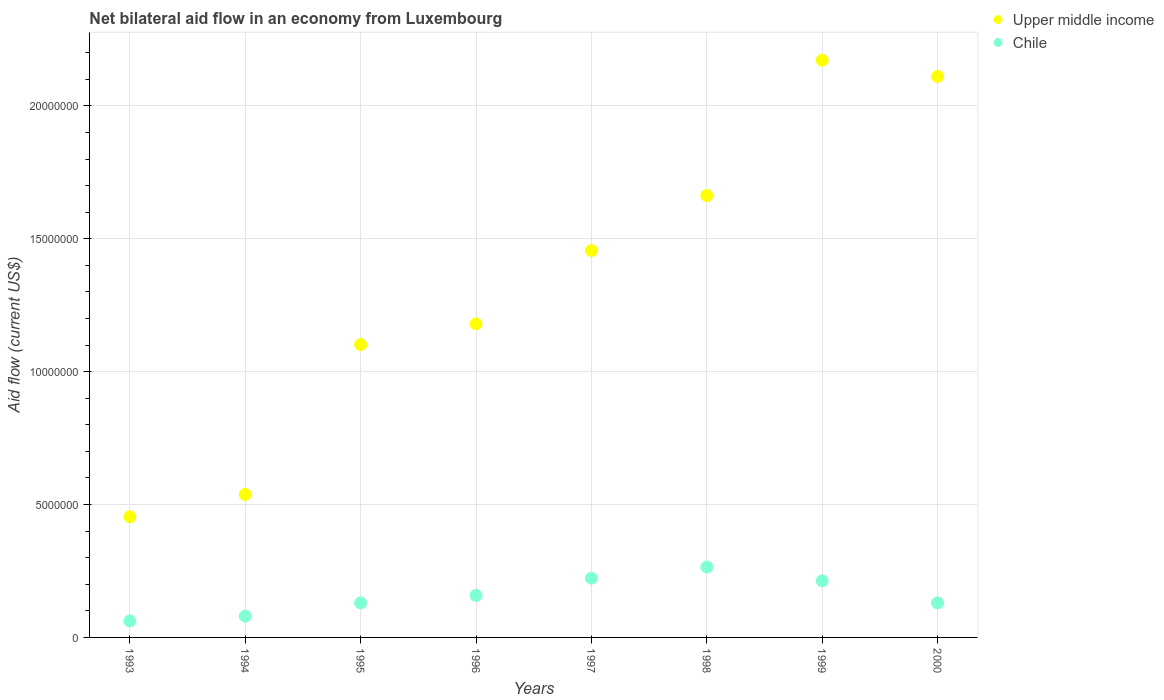Is the number of dotlines equal to the number of legend labels?
Provide a short and direct response. Yes. What is the net bilateral aid flow in Chile in 2000?
Keep it short and to the point. 1.30e+06. Across all years, what is the maximum net bilateral aid flow in Chile?
Offer a very short reply. 2.65e+06. Across all years, what is the minimum net bilateral aid flow in Upper middle income?
Your response must be concise. 4.54e+06. In which year was the net bilateral aid flow in Chile minimum?
Ensure brevity in your answer.  1993. What is the total net bilateral aid flow in Upper middle income in the graph?
Your response must be concise. 1.07e+08. What is the difference between the net bilateral aid flow in Upper middle income in 1998 and that in 1999?
Keep it short and to the point. -5.09e+06. What is the difference between the net bilateral aid flow in Chile in 1994 and the net bilateral aid flow in Upper middle income in 1996?
Give a very brief answer. -1.10e+07. What is the average net bilateral aid flow in Upper middle income per year?
Make the answer very short. 1.33e+07. In the year 1993, what is the difference between the net bilateral aid flow in Upper middle income and net bilateral aid flow in Chile?
Provide a short and direct response. 3.92e+06. In how many years, is the net bilateral aid flow in Upper middle income greater than 5000000 US$?
Provide a short and direct response. 7. What is the ratio of the net bilateral aid flow in Chile in 1993 to that in 1994?
Your answer should be very brief. 0.78. Is the net bilateral aid flow in Chile in 1994 less than that in 1998?
Provide a short and direct response. Yes. What is the difference between the highest and the second highest net bilateral aid flow in Chile?
Provide a succinct answer. 4.20e+05. What is the difference between the highest and the lowest net bilateral aid flow in Upper middle income?
Your response must be concise. 1.72e+07. Is the sum of the net bilateral aid flow in Chile in 1994 and 1998 greater than the maximum net bilateral aid flow in Upper middle income across all years?
Offer a very short reply. No. Does the net bilateral aid flow in Chile monotonically increase over the years?
Offer a terse response. No. Where does the legend appear in the graph?
Your response must be concise. Top right. How many legend labels are there?
Provide a short and direct response. 2. How are the legend labels stacked?
Keep it short and to the point. Vertical. What is the title of the graph?
Provide a short and direct response. Net bilateral aid flow in an economy from Luxembourg. What is the Aid flow (current US$) of Upper middle income in 1993?
Offer a terse response. 4.54e+06. What is the Aid flow (current US$) of Chile in 1993?
Provide a succinct answer. 6.20e+05. What is the Aid flow (current US$) of Upper middle income in 1994?
Your answer should be compact. 5.38e+06. What is the Aid flow (current US$) of Upper middle income in 1995?
Ensure brevity in your answer.  1.10e+07. What is the Aid flow (current US$) in Chile in 1995?
Make the answer very short. 1.30e+06. What is the Aid flow (current US$) in Upper middle income in 1996?
Provide a short and direct response. 1.18e+07. What is the Aid flow (current US$) in Chile in 1996?
Make the answer very short. 1.58e+06. What is the Aid flow (current US$) of Upper middle income in 1997?
Offer a terse response. 1.46e+07. What is the Aid flow (current US$) of Chile in 1997?
Provide a succinct answer. 2.23e+06. What is the Aid flow (current US$) in Upper middle income in 1998?
Make the answer very short. 1.66e+07. What is the Aid flow (current US$) of Chile in 1998?
Your response must be concise. 2.65e+06. What is the Aid flow (current US$) of Upper middle income in 1999?
Make the answer very short. 2.17e+07. What is the Aid flow (current US$) of Chile in 1999?
Your answer should be compact. 2.13e+06. What is the Aid flow (current US$) in Upper middle income in 2000?
Give a very brief answer. 2.11e+07. What is the Aid flow (current US$) of Chile in 2000?
Offer a very short reply. 1.30e+06. Across all years, what is the maximum Aid flow (current US$) in Upper middle income?
Offer a terse response. 2.17e+07. Across all years, what is the maximum Aid flow (current US$) in Chile?
Provide a short and direct response. 2.65e+06. Across all years, what is the minimum Aid flow (current US$) in Upper middle income?
Offer a very short reply. 4.54e+06. Across all years, what is the minimum Aid flow (current US$) in Chile?
Provide a succinct answer. 6.20e+05. What is the total Aid flow (current US$) in Upper middle income in the graph?
Your answer should be very brief. 1.07e+08. What is the total Aid flow (current US$) in Chile in the graph?
Your answer should be very brief. 1.26e+07. What is the difference between the Aid flow (current US$) of Upper middle income in 1993 and that in 1994?
Keep it short and to the point. -8.40e+05. What is the difference between the Aid flow (current US$) in Upper middle income in 1993 and that in 1995?
Ensure brevity in your answer.  -6.48e+06. What is the difference between the Aid flow (current US$) in Chile in 1993 and that in 1995?
Ensure brevity in your answer.  -6.80e+05. What is the difference between the Aid flow (current US$) in Upper middle income in 1993 and that in 1996?
Offer a very short reply. -7.26e+06. What is the difference between the Aid flow (current US$) in Chile in 1993 and that in 1996?
Provide a short and direct response. -9.60e+05. What is the difference between the Aid flow (current US$) in Upper middle income in 1993 and that in 1997?
Make the answer very short. -1.00e+07. What is the difference between the Aid flow (current US$) of Chile in 1993 and that in 1997?
Give a very brief answer. -1.61e+06. What is the difference between the Aid flow (current US$) of Upper middle income in 1993 and that in 1998?
Provide a succinct answer. -1.21e+07. What is the difference between the Aid flow (current US$) of Chile in 1993 and that in 1998?
Offer a terse response. -2.03e+06. What is the difference between the Aid flow (current US$) of Upper middle income in 1993 and that in 1999?
Give a very brief answer. -1.72e+07. What is the difference between the Aid flow (current US$) of Chile in 1993 and that in 1999?
Ensure brevity in your answer.  -1.51e+06. What is the difference between the Aid flow (current US$) in Upper middle income in 1993 and that in 2000?
Ensure brevity in your answer.  -1.66e+07. What is the difference between the Aid flow (current US$) of Chile in 1993 and that in 2000?
Offer a terse response. -6.80e+05. What is the difference between the Aid flow (current US$) in Upper middle income in 1994 and that in 1995?
Your response must be concise. -5.64e+06. What is the difference between the Aid flow (current US$) in Chile in 1994 and that in 1995?
Give a very brief answer. -5.00e+05. What is the difference between the Aid flow (current US$) in Upper middle income in 1994 and that in 1996?
Provide a short and direct response. -6.42e+06. What is the difference between the Aid flow (current US$) of Chile in 1994 and that in 1996?
Your answer should be very brief. -7.80e+05. What is the difference between the Aid flow (current US$) of Upper middle income in 1994 and that in 1997?
Give a very brief answer. -9.18e+06. What is the difference between the Aid flow (current US$) of Chile in 1994 and that in 1997?
Provide a succinct answer. -1.43e+06. What is the difference between the Aid flow (current US$) of Upper middle income in 1994 and that in 1998?
Offer a terse response. -1.12e+07. What is the difference between the Aid flow (current US$) in Chile in 1994 and that in 1998?
Your answer should be compact. -1.85e+06. What is the difference between the Aid flow (current US$) of Upper middle income in 1994 and that in 1999?
Provide a succinct answer. -1.63e+07. What is the difference between the Aid flow (current US$) of Chile in 1994 and that in 1999?
Provide a succinct answer. -1.33e+06. What is the difference between the Aid flow (current US$) in Upper middle income in 1994 and that in 2000?
Keep it short and to the point. -1.57e+07. What is the difference between the Aid flow (current US$) in Chile in 1994 and that in 2000?
Keep it short and to the point. -5.00e+05. What is the difference between the Aid flow (current US$) in Upper middle income in 1995 and that in 1996?
Your answer should be very brief. -7.80e+05. What is the difference between the Aid flow (current US$) of Chile in 1995 and that in 1996?
Make the answer very short. -2.80e+05. What is the difference between the Aid flow (current US$) of Upper middle income in 1995 and that in 1997?
Offer a terse response. -3.54e+06. What is the difference between the Aid flow (current US$) of Chile in 1995 and that in 1997?
Your response must be concise. -9.30e+05. What is the difference between the Aid flow (current US$) of Upper middle income in 1995 and that in 1998?
Keep it short and to the point. -5.61e+06. What is the difference between the Aid flow (current US$) in Chile in 1995 and that in 1998?
Make the answer very short. -1.35e+06. What is the difference between the Aid flow (current US$) in Upper middle income in 1995 and that in 1999?
Your response must be concise. -1.07e+07. What is the difference between the Aid flow (current US$) of Chile in 1995 and that in 1999?
Give a very brief answer. -8.30e+05. What is the difference between the Aid flow (current US$) of Upper middle income in 1995 and that in 2000?
Your response must be concise. -1.01e+07. What is the difference between the Aid flow (current US$) of Upper middle income in 1996 and that in 1997?
Your answer should be compact. -2.76e+06. What is the difference between the Aid flow (current US$) in Chile in 1996 and that in 1997?
Your answer should be very brief. -6.50e+05. What is the difference between the Aid flow (current US$) of Upper middle income in 1996 and that in 1998?
Offer a terse response. -4.83e+06. What is the difference between the Aid flow (current US$) in Chile in 1996 and that in 1998?
Provide a succinct answer. -1.07e+06. What is the difference between the Aid flow (current US$) of Upper middle income in 1996 and that in 1999?
Keep it short and to the point. -9.92e+06. What is the difference between the Aid flow (current US$) of Chile in 1996 and that in 1999?
Provide a succinct answer. -5.50e+05. What is the difference between the Aid flow (current US$) of Upper middle income in 1996 and that in 2000?
Your answer should be compact. -9.31e+06. What is the difference between the Aid flow (current US$) in Chile in 1996 and that in 2000?
Provide a short and direct response. 2.80e+05. What is the difference between the Aid flow (current US$) in Upper middle income in 1997 and that in 1998?
Keep it short and to the point. -2.07e+06. What is the difference between the Aid flow (current US$) in Chile in 1997 and that in 1998?
Keep it short and to the point. -4.20e+05. What is the difference between the Aid flow (current US$) of Upper middle income in 1997 and that in 1999?
Provide a succinct answer. -7.16e+06. What is the difference between the Aid flow (current US$) in Chile in 1997 and that in 1999?
Make the answer very short. 1.00e+05. What is the difference between the Aid flow (current US$) of Upper middle income in 1997 and that in 2000?
Give a very brief answer. -6.55e+06. What is the difference between the Aid flow (current US$) in Chile in 1997 and that in 2000?
Keep it short and to the point. 9.30e+05. What is the difference between the Aid flow (current US$) of Upper middle income in 1998 and that in 1999?
Your answer should be very brief. -5.09e+06. What is the difference between the Aid flow (current US$) of Chile in 1998 and that in 1999?
Your response must be concise. 5.20e+05. What is the difference between the Aid flow (current US$) of Upper middle income in 1998 and that in 2000?
Offer a terse response. -4.48e+06. What is the difference between the Aid flow (current US$) of Chile in 1998 and that in 2000?
Offer a terse response. 1.35e+06. What is the difference between the Aid flow (current US$) of Chile in 1999 and that in 2000?
Offer a terse response. 8.30e+05. What is the difference between the Aid flow (current US$) of Upper middle income in 1993 and the Aid flow (current US$) of Chile in 1994?
Give a very brief answer. 3.74e+06. What is the difference between the Aid flow (current US$) of Upper middle income in 1993 and the Aid flow (current US$) of Chile in 1995?
Ensure brevity in your answer.  3.24e+06. What is the difference between the Aid flow (current US$) in Upper middle income in 1993 and the Aid flow (current US$) in Chile in 1996?
Provide a short and direct response. 2.96e+06. What is the difference between the Aid flow (current US$) of Upper middle income in 1993 and the Aid flow (current US$) of Chile in 1997?
Give a very brief answer. 2.31e+06. What is the difference between the Aid flow (current US$) of Upper middle income in 1993 and the Aid flow (current US$) of Chile in 1998?
Ensure brevity in your answer.  1.89e+06. What is the difference between the Aid flow (current US$) in Upper middle income in 1993 and the Aid flow (current US$) in Chile in 1999?
Provide a short and direct response. 2.41e+06. What is the difference between the Aid flow (current US$) of Upper middle income in 1993 and the Aid flow (current US$) of Chile in 2000?
Provide a short and direct response. 3.24e+06. What is the difference between the Aid flow (current US$) in Upper middle income in 1994 and the Aid flow (current US$) in Chile in 1995?
Your answer should be very brief. 4.08e+06. What is the difference between the Aid flow (current US$) of Upper middle income in 1994 and the Aid flow (current US$) of Chile in 1996?
Offer a very short reply. 3.80e+06. What is the difference between the Aid flow (current US$) in Upper middle income in 1994 and the Aid flow (current US$) in Chile in 1997?
Give a very brief answer. 3.15e+06. What is the difference between the Aid flow (current US$) of Upper middle income in 1994 and the Aid flow (current US$) of Chile in 1998?
Keep it short and to the point. 2.73e+06. What is the difference between the Aid flow (current US$) in Upper middle income in 1994 and the Aid flow (current US$) in Chile in 1999?
Provide a succinct answer. 3.25e+06. What is the difference between the Aid flow (current US$) of Upper middle income in 1994 and the Aid flow (current US$) of Chile in 2000?
Provide a succinct answer. 4.08e+06. What is the difference between the Aid flow (current US$) in Upper middle income in 1995 and the Aid flow (current US$) in Chile in 1996?
Give a very brief answer. 9.44e+06. What is the difference between the Aid flow (current US$) in Upper middle income in 1995 and the Aid flow (current US$) in Chile in 1997?
Give a very brief answer. 8.79e+06. What is the difference between the Aid flow (current US$) of Upper middle income in 1995 and the Aid flow (current US$) of Chile in 1998?
Ensure brevity in your answer.  8.37e+06. What is the difference between the Aid flow (current US$) of Upper middle income in 1995 and the Aid flow (current US$) of Chile in 1999?
Provide a short and direct response. 8.89e+06. What is the difference between the Aid flow (current US$) of Upper middle income in 1995 and the Aid flow (current US$) of Chile in 2000?
Offer a very short reply. 9.72e+06. What is the difference between the Aid flow (current US$) of Upper middle income in 1996 and the Aid flow (current US$) of Chile in 1997?
Provide a succinct answer. 9.57e+06. What is the difference between the Aid flow (current US$) of Upper middle income in 1996 and the Aid flow (current US$) of Chile in 1998?
Offer a very short reply. 9.15e+06. What is the difference between the Aid flow (current US$) in Upper middle income in 1996 and the Aid flow (current US$) in Chile in 1999?
Make the answer very short. 9.67e+06. What is the difference between the Aid flow (current US$) in Upper middle income in 1996 and the Aid flow (current US$) in Chile in 2000?
Your response must be concise. 1.05e+07. What is the difference between the Aid flow (current US$) of Upper middle income in 1997 and the Aid flow (current US$) of Chile in 1998?
Your response must be concise. 1.19e+07. What is the difference between the Aid flow (current US$) in Upper middle income in 1997 and the Aid flow (current US$) in Chile in 1999?
Make the answer very short. 1.24e+07. What is the difference between the Aid flow (current US$) of Upper middle income in 1997 and the Aid flow (current US$) of Chile in 2000?
Ensure brevity in your answer.  1.33e+07. What is the difference between the Aid flow (current US$) of Upper middle income in 1998 and the Aid flow (current US$) of Chile in 1999?
Provide a short and direct response. 1.45e+07. What is the difference between the Aid flow (current US$) in Upper middle income in 1998 and the Aid flow (current US$) in Chile in 2000?
Give a very brief answer. 1.53e+07. What is the difference between the Aid flow (current US$) of Upper middle income in 1999 and the Aid flow (current US$) of Chile in 2000?
Provide a short and direct response. 2.04e+07. What is the average Aid flow (current US$) of Upper middle income per year?
Make the answer very short. 1.33e+07. What is the average Aid flow (current US$) of Chile per year?
Ensure brevity in your answer.  1.58e+06. In the year 1993, what is the difference between the Aid flow (current US$) in Upper middle income and Aid flow (current US$) in Chile?
Your response must be concise. 3.92e+06. In the year 1994, what is the difference between the Aid flow (current US$) of Upper middle income and Aid flow (current US$) of Chile?
Provide a short and direct response. 4.58e+06. In the year 1995, what is the difference between the Aid flow (current US$) of Upper middle income and Aid flow (current US$) of Chile?
Offer a terse response. 9.72e+06. In the year 1996, what is the difference between the Aid flow (current US$) of Upper middle income and Aid flow (current US$) of Chile?
Ensure brevity in your answer.  1.02e+07. In the year 1997, what is the difference between the Aid flow (current US$) in Upper middle income and Aid flow (current US$) in Chile?
Provide a succinct answer. 1.23e+07. In the year 1998, what is the difference between the Aid flow (current US$) in Upper middle income and Aid flow (current US$) in Chile?
Ensure brevity in your answer.  1.40e+07. In the year 1999, what is the difference between the Aid flow (current US$) in Upper middle income and Aid flow (current US$) in Chile?
Your answer should be very brief. 1.96e+07. In the year 2000, what is the difference between the Aid flow (current US$) of Upper middle income and Aid flow (current US$) of Chile?
Your answer should be very brief. 1.98e+07. What is the ratio of the Aid flow (current US$) in Upper middle income in 1993 to that in 1994?
Ensure brevity in your answer.  0.84. What is the ratio of the Aid flow (current US$) of Chile in 1993 to that in 1994?
Your response must be concise. 0.78. What is the ratio of the Aid flow (current US$) in Upper middle income in 1993 to that in 1995?
Make the answer very short. 0.41. What is the ratio of the Aid flow (current US$) of Chile in 1993 to that in 1995?
Offer a very short reply. 0.48. What is the ratio of the Aid flow (current US$) in Upper middle income in 1993 to that in 1996?
Give a very brief answer. 0.38. What is the ratio of the Aid flow (current US$) in Chile in 1993 to that in 1996?
Offer a terse response. 0.39. What is the ratio of the Aid flow (current US$) of Upper middle income in 1993 to that in 1997?
Offer a terse response. 0.31. What is the ratio of the Aid flow (current US$) of Chile in 1993 to that in 1997?
Your answer should be very brief. 0.28. What is the ratio of the Aid flow (current US$) in Upper middle income in 1993 to that in 1998?
Offer a terse response. 0.27. What is the ratio of the Aid flow (current US$) of Chile in 1993 to that in 1998?
Give a very brief answer. 0.23. What is the ratio of the Aid flow (current US$) of Upper middle income in 1993 to that in 1999?
Give a very brief answer. 0.21. What is the ratio of the Aid flow (current US$) in Chile in 1993 to that in 1999?
Provide a succinct answer. 0.29. What is the ratio of the Aid flow (current US$) of Upper middle income in 1993 to that in 2000?
Offer a terse response. 0.22. What is the ratio of the Aid flow (current US$) in Chile in 1993 to that in 2000?
Offer a terse response. 0.48. What is the ratio of the Aid flow (current US$) of Upper middle income in 1994 to that in 1995?
Keep it short and to the point. 0.49. What is the ratio of the Aid flow (current US$) of Chile in 1994 to that in 1995?
Your response must be concise. 0.62. What is the ratio of the Aid flow (current US$) in Upper middle income in 1994 to that in 1996?
Your response must be concise. 0.46. What is the ratio of the Aid flow (current US$) of Chile in 1994 to that in 1996?
Offer a very short reply. 0.51. What is the ratio of the Aid flow (current US$) in Upper middle income in 1994 to that in 1997?
Your answer should be very brief. 0.37. What is the ratio of the Aid flow (current US$) in Chile in 1994 to that in 1997?
Your response must be concise. 0.36. What is the ratio of the Aid flow (current US$) in Upper middle income in 1994 to that in 1998?
Offer a very short reply. 0.32. What is the ratio of the Aid flow (current US$) of Chile in 1994 to that in 1998?
Offer a terse response. 0.3. What is the ratio of the Aid flow (current US$) of Upper middle income in 1994 to that in 1999?
Keep it short and to the point. 0.25. What is the ratio of the Aid flow (current US$) in Chile in 1994 to that in 1999?
Make the answer very short. 0.38. What is the ratio of the Aid flow (current US$) in Upper middle income in 1994 to that in 2000?
Your response must be concise. 0.25. What is the ratio of the Aid flow (current US$) of Chile in 1994 to that in 2000?
Offer a terse response. 0.62. What is the ratio of the Aid flow (current US$) of Upper middle income in 1995 to that in 1996?
Make the answer very short. 0.93. What is the ratio of the Aid flow (current US$) in Chile in 1995 to that in 1996?
Offer a very short reply. 0.82. What is the ratio of the Aid flow (current US$) in Upper middle income in 1995 to that in 1997?
Your response must be concise. 0.76. What is the ratio of the Aid flow (current US$) in Chile in 1995 to that in 1997?
Keep it short and to the point. 0.58. What is the ratio of the Aid flow (current US$) of Upper middle income in 1995 to that in 1998?
Offer a terse response. 0.66. What is the ratio of the Aid flow (current US$) in Chile in 1995 to that in 1998?
Offer a very short reply. 0.49. What is the ratio of the Aid flow (current US$) of Upper middle income in 1995 to that in 1999?
Your answer should be very brief. 0.51. What is the ratio of the Aid flow (current US$) in Chile in 1995 to that in 1999?
Offer a terse response. 0.61. What is the ratio of the Aid flow (current US$) in Upper middle income in 1995 to that in 2000?
Ensure brevity in your answer.  0.52. What is the ratio of the Aid flow (current US$) of Chile in 1995 to that in 2000?
Your response must be concise. 1. What is the ratio of the Aid flow (current US$) of Upper middle income in 1996 to that in 1997?
Ensure brevity in your answer.  0.81. What is the ratio of the Aid flow (current US$) of Chile in 1996 to that in 1997?
Keep it short and to the point. 0.71. What is the ratio of the Aid flow (current US$) in Upper middle income in 1996 to that in 1998?
Provide a succinct answer. 0.71. What is the ratio of the Aid flow (current US$) in Chile in 1996 to that in 1998?
Offer a terse response. 0.6. What is the ratio of the Aid flow (current US$) in Upper middle income in 1996 to that in 1999?
Make the answer very short. 0.54. What is the ratio of the Aid flow (current US$) in Chile in 1996 to that in 1999?
Your answer should be very brief. 0.74. What is the ratio of the Aid flow (current US$) in Upper middle income in 1996 to that in 2000?
Offer a very short reply. 0.56. What is the ratio of the Aid flow (current US$) in Chile in 1996 to that in 2000?
Provide a short and direct response. 1.22. What is the ratio of the Aid flow (current US$) of Upper middle income in 1997 to that in 1998?
Offer a terse response. 0.88. What is the ratio of the Aid flow (current US$) in Chile in 1997 to that in 1998?
Give a very brief answer. 0.84. What is the ratio of the Aid flow (current US$) of Upper middle income in 1997 to that in 1999?
Offer a very short reply. 0.67. What is the ratio of the Aid flow (current US$) in Chile in 1997 to that in 1999?
Your answer should be very brief. 1.05. What is the ratio of the Aid flow (current US$) in Upper middle income in 1997 to that in 2000?
Your answer should be very brief. 0.69. What is the ratio of the Aid flow (current US$) in Chile in 1997 to that in 2000?
Your answer should be very brief. 1.72. What is the ratio of the Aid flow (current US$) in Upper middle income in 1998 to that in 1999?
Offer a terse response. 0.77. What is the ratio of the Aid flow (current US$) of Chile in 1998 to that in 1999?
Provide a succinct answer. 1.24. What is the ratio of the Aid flow (current US$) in Upper middle income in 1998 to that in 2000?
Provide a succinct answer. 0.79. What is the ratio of the Aid flow (current US$) of Chile in 1998 to that in 2000?
Make the answer very short. 2.04. What is the ratio of the Aid flow (current US$) in Upper middle income in 1999 to that in 2000?
Ensure brevity in your answer.  1.03. What is the ratio of the Aid flow (current US$) in Chile in 1999 to that in 2000?
Provide a succinct answer. 1.64. What is the difference between the highest and the second highest Aid flow (current US$) in Upper middle income?
Provide a short and direct response. 6.10e+05. What is the difference between the highest and the second highest Aid flow (current US$) in Chile?
Keep it short and to the point. 4.20e+05. What is the difference between the highest and the lowest Aid flow (current US$) in Upper middle income?
Provide a short and direct response. 1.72e+07. What is the difference between the highest and the lowest Aid flow (current US$) in Chile?
Offer a terse response. 2.03e+06. 